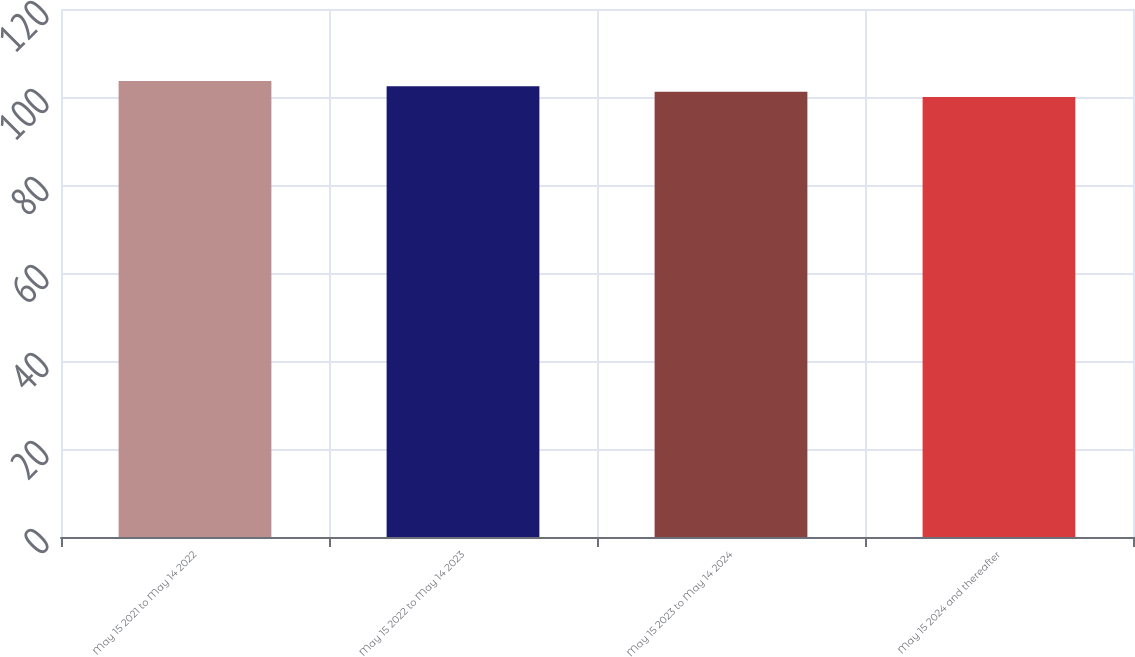Convert chart. <chart><loc_0><loc_0><loc_500><loc_500><bar_chart><fcel>May 15 2021 to May 14 2022<fcel>May 15 2022 to May 14 2023<fcel>May 15 2023 to May 14 2024<fcel>May 15 2024 and thereafter<nl><fcel>103.62<fcel>102.42<fcel>101.21<fcel>100<nl></chart> 